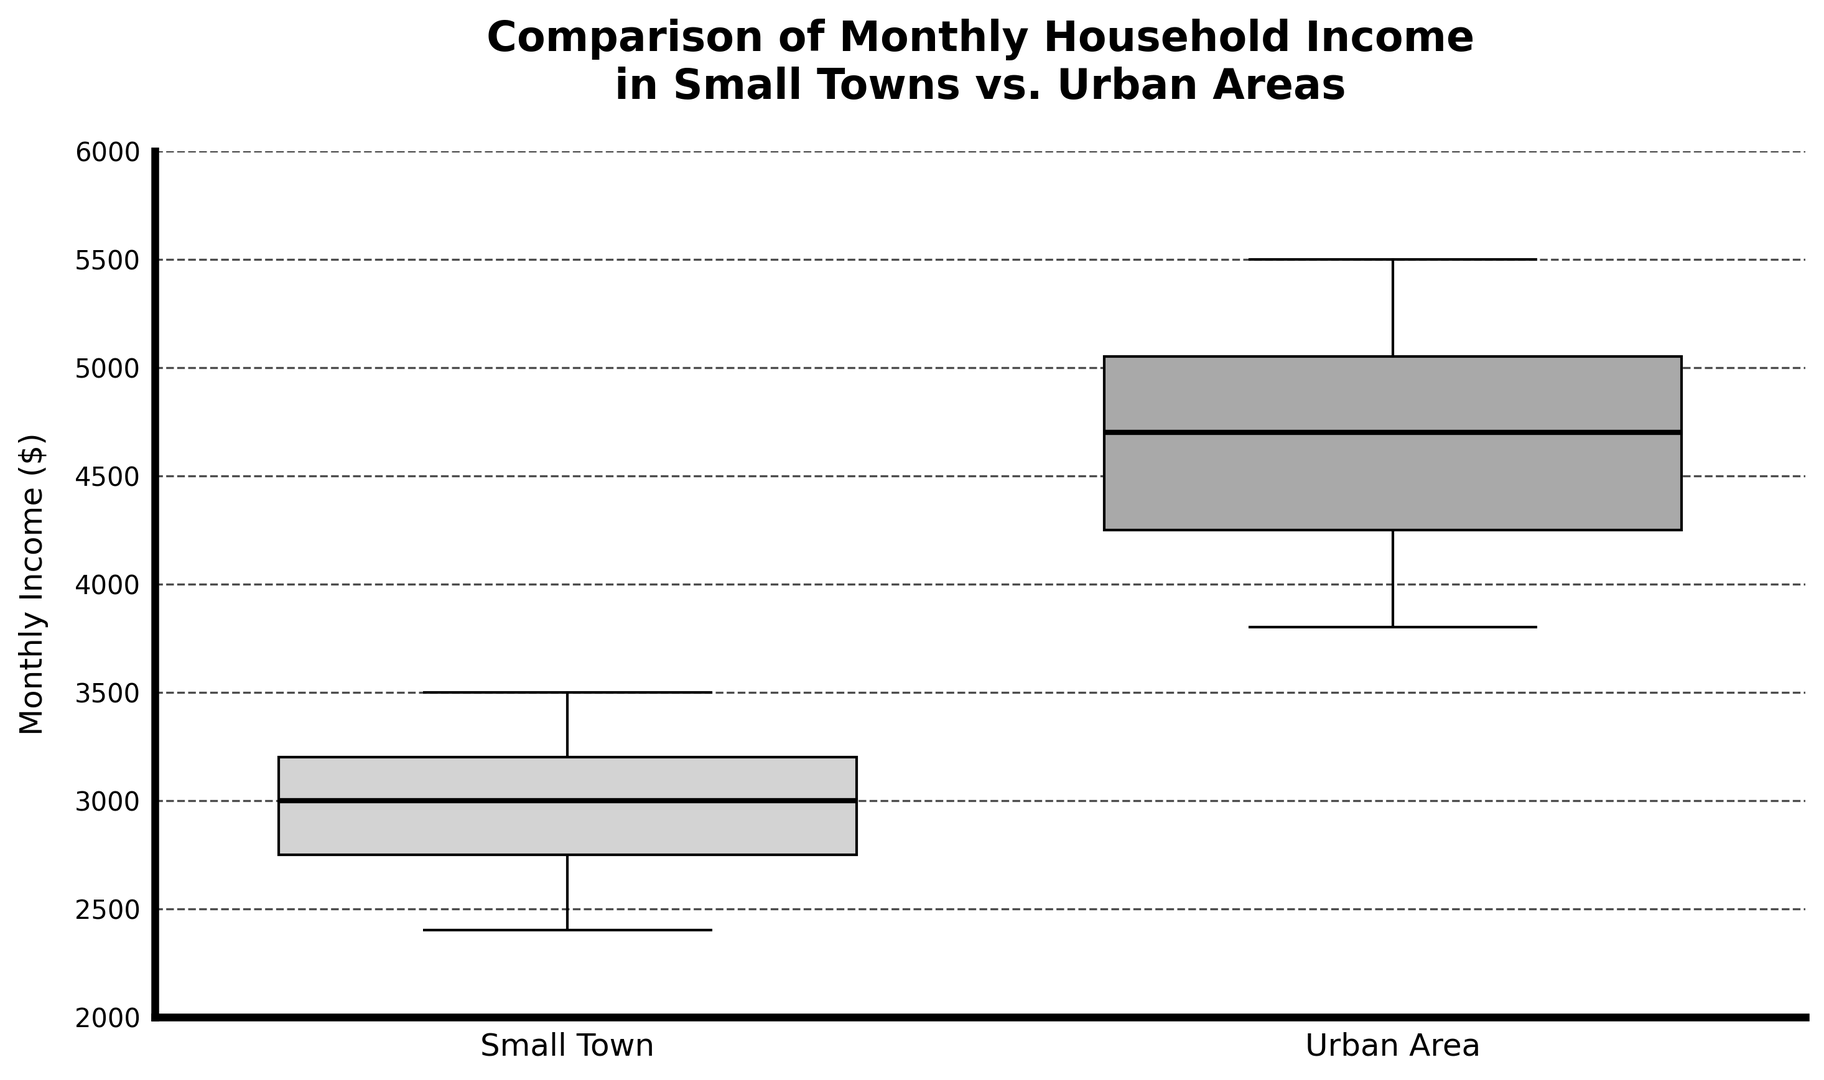What is the median monthly income for households in small towns? To find the median, look at the horizontal line inside the box for Small Towns. This represents the median value.
Answer: 3000 What is the interquartile range (IQR) for monthly household incomes in urban areas? The IQR is calculated by subtracting the lower quartile (Q1) from the upper quartile (Q3). Identify the bottom and top edges of the box for Urban Areas, which represent Q1 and Q3. Subtract the value at the bottom edge from the value at the top edge of the box.
Answer: 1100 Which area has a higher median monthly household income? Compare the horizontal lines within the boxes for Small Towns and Urban Areas. The line inside the box for Urban Areas is higher than that for Small Towns, indicating a higher median value.
Answer: Urban Areas Are there any outliers in the monthly household incomes for small towns? Outliers are represented by markers outside the "whiskers" (lines extending from the boxes). Check if any points are visibly separate from the whiskers in the Small Towns category.
Answer: No What is the range of monthly household incomes in small towns? The range is the difference between the maximum and minimum values represented by the ends of the whiskers. Examine the lowest point of the lower whisker and the highest point of the upper whisker for Small Towns, then subtract the minimum from the maximum.
Answer: 1100 How does the spread of household incomes compare between small towns and urban areas? Look at the length of the boxes and whiskers for both categories. A longer box and whiskers indicate a larger spread. The Urban Areas boxplot appears to have longer whiskers and a box compared to Small Towns, indicating a wider spread.
Answer: Urban Areas have a larger spread What are the third quartile (Q3) values for both small towns and urban areas? Identify the top edges of the boxes for both categories. These edges represent the third quartile (Q3) values. Read the values for both Small Towns and Urban Areas.
Answer: Small Towns: 3200, Urban Areas: 4900 How do the lower quartile (Q1) values compare between small towns and urban areas? Identify the bottom edges of the boxes for both categories. Compare these values by reading them from the plot.
Answer: Small Towns: 2700, Urban Areas: 3800 Approximately, what is the difference between the maximum income in urban areas and the maximum income in small towns? Identify the highest point of the top whisker for both categories. Subtract the maximum value in Small Towns from the maximum value in Urban Areas.
Answer: 2000 Are there more variations in monthly incomes in urban areas compared to small towns? Assess the lengths of the boxes and whiskers. More variations are indicated by longer box plots and whiskers. Urban Areas display a longer box and whiskers compared to Small Towns, suggesting more variation.
Answer: Yes 